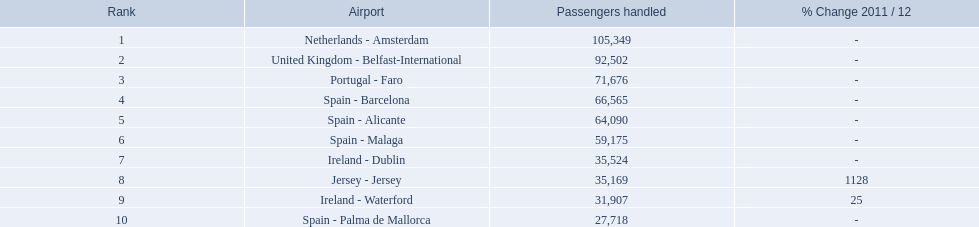What are the names of all the airports? Netherlands - Amsterdam, United Kingdom - Belfast-International, Portugal - Faro, Spain - Barcelona, Spain - Alicante, Spain - Malaga, Ireland - Dublin, Jersey - Jersey, Ireland - Waterford, Spain - Palma de Mallorca. Of these, what are all the passenger counts? 105,349, 92,502, 71,676, 66,565, 64,090, 59,175, 35,524, 35,169, 31,907, 27,718. Of these, which airport had more passengers than the united kingdom? Netherlands - Amsterdam. What is the top position? 1. What is the airfield? Netherlands - Amsterdam. 